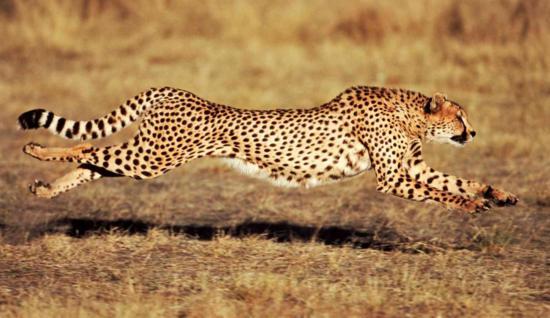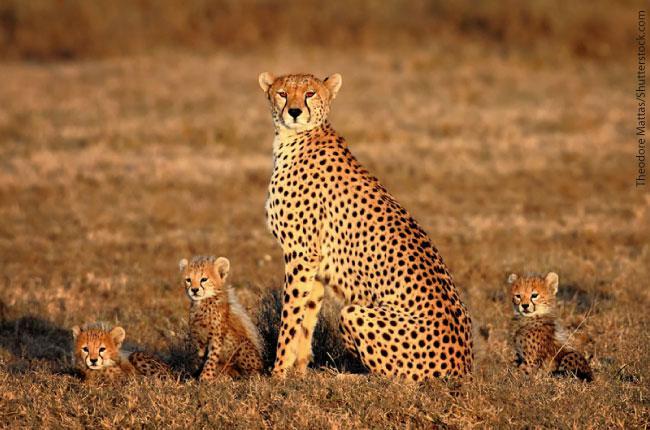The first image is the image on the left, the second image is the image on the right. Examine the images to the left and right. Is the description "There is a single cheetah running in the left image." accurate? Answer yes or no. Yes. The first image is the image on the left, the second image is the image on the right. Examine the images to the left and right. Is the description "Not more than one cheetah in any of the pictures" accurate? Answer yes or no. No. 